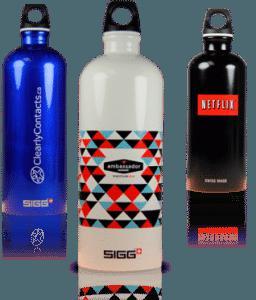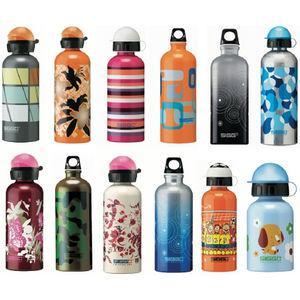The first image is the image on the left, the second image is the image on the right. Examine the images to the left and right. Is the description "There are more bottles in the left image than the right." accurate? Answer yes or no. No. 